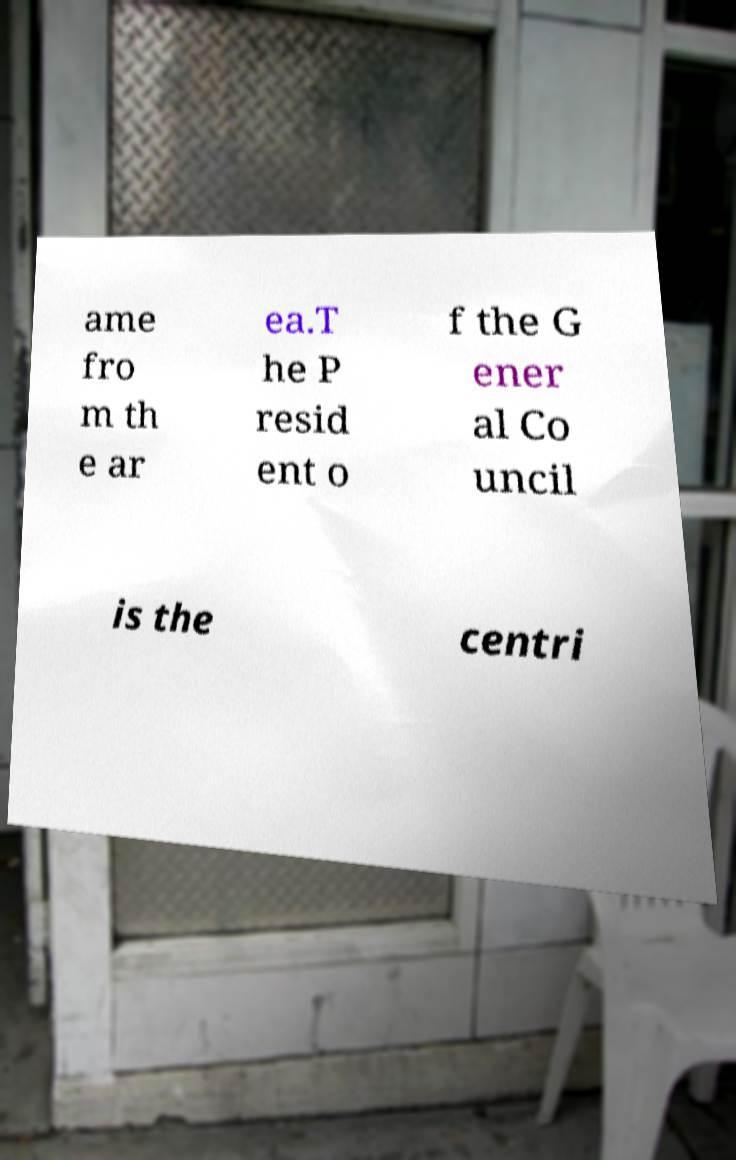I need the written content from this picture converted into text. Can you do that? ame fro m th e ar ea.T he P resid ent o f the G ener al Co uncil is the centri 